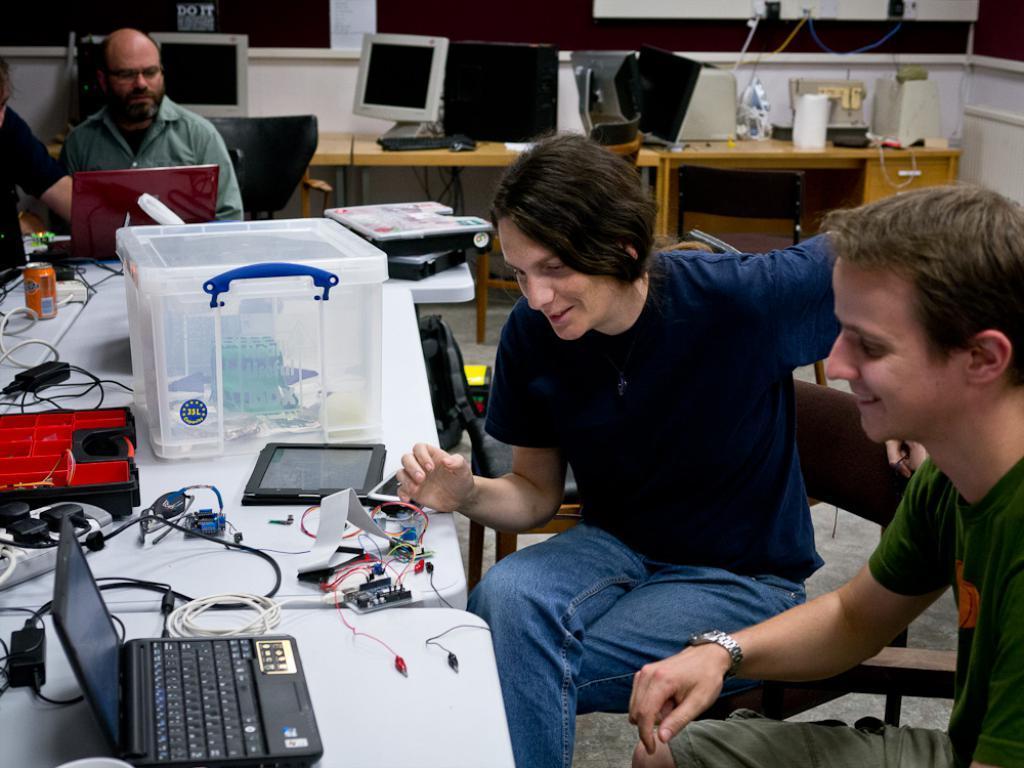Please provide a concise description of this image. In this image we can see two people seated in chairs, with a smile on their face, in front of them there is a table, on the table there is a laptop, a few cables and some other stuff, behind the two people there are computers placed on tables and there are two other people seated on chairs. 